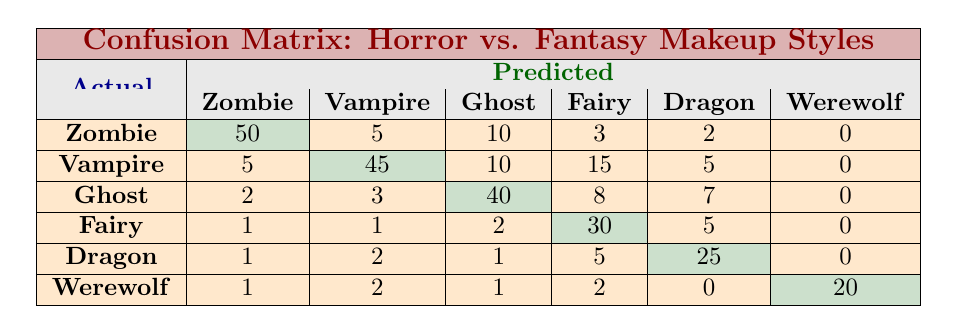What is the predicted value for Zombie makeup style? In the table, under the predicted class column for the actual class Zombie, the value is 50.
Answer: 50 What was the actual prediction for Ghost? In the actual row for Ghost, the predicted classification shows 40 for Ghost makeup style.
Answer: 40 Does the model predict Vampires more accurately than Fairies? Yes, for Vampires, the true positive prediction is 45, while for Fairies, it is only 30.
Answer: Yes What is the total number of predictions made for Dragon? To find the total predictions for Dragon, add the numbers from its row: 1 + 2 + 1 + 5 + 25 = 34.
Answer: 34 How many makeup styles did the model classify as Werewolf? In the Werewolf row, the predicted value is 20, which represents the correct classification for Werewolf.
Answer: 20 What is the average number of correct predictions for all makeup styles? Calculate the sum of the diagonal values: 50 + 45 + 40 + 30 + 25 + 20 = 210. There are 6 makeup styles, so the average is 210 / 6 = 35.
Answer: 35 For which makeup style does the model have the highest number of incorrect predictions? By looking at the off-diagonal values for each row, the highest incorrect prediction is for Vamps, having a total of 35 errors (5 + 10 + 15 + 5).
Answer: Vampire Is there any makeup style that has no predictions made for it at all? No, every makeup style has at least one prediction value associated with it, indicating that all have been classified in some capacity.
Answer: No What percentage of predictions for Werewolf were correct? The correct predictions for Werewolf are 20, and the total predictions made for Werewolf are 26 (1 + 2 + 1 + 2 + 0 + 20). Calculate (20/26)*100 and it equals approximately 76.92%.
Answer: 76.92% 